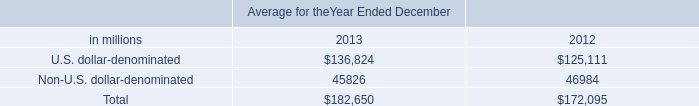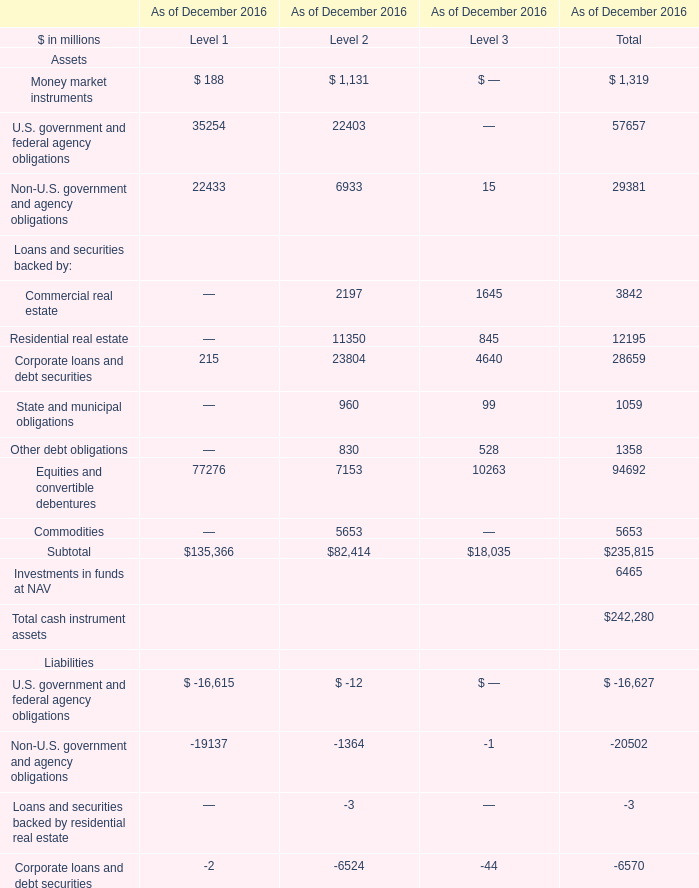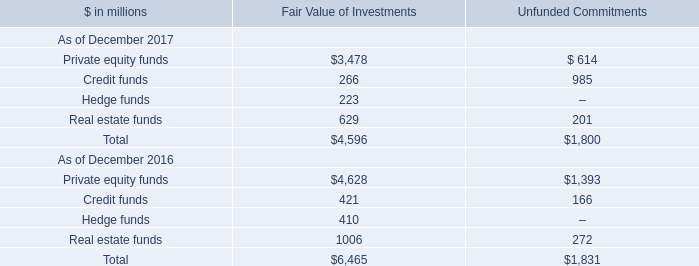In what sections is Non-U.S. government and agency obligations greater than 20000? 
Answer: Level 1. 